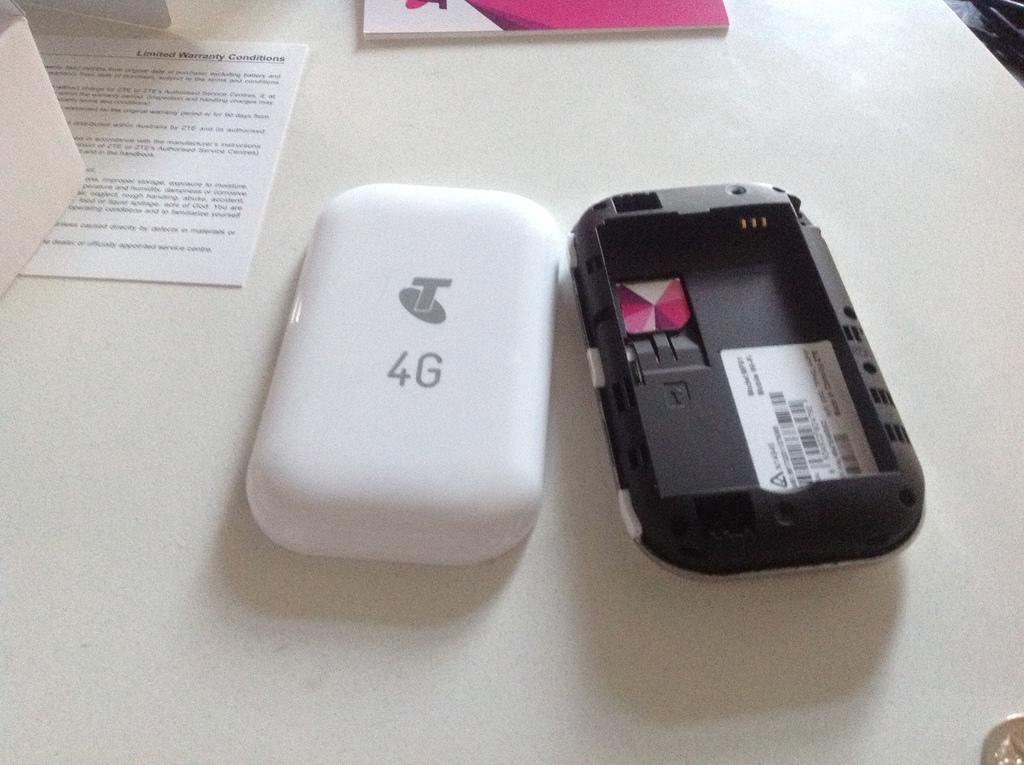<image>
Present a compact description of the photo's key features. A phone that has been taken apart and has 4G on the front cover. 